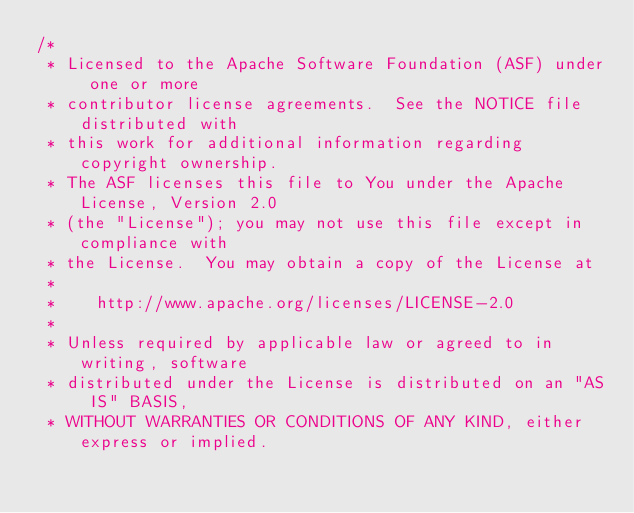Convert code to text. <code><loc_0><loc_0><loc_500><loc_500><_SQL_>/*
 * Licensed to the Apache Software Foundation (ASF) under one or more
 * contributor license agreements.  See the NOTICE file distributed with
 * this work for additional information regarding copyright ownership.
 * The ASF licenses this file to You under the Apache License, Version 2.0
 * (the "License"); you may not use this file except in compliance with
 * the License.  You may obtain a copy of the License at
 *
 *    http://www.apache.org/licenses/LICENSE-2.0
 *
 * Unless required by applicable law or agreed to in writing, software
 * distributed under the License is distributed on an "AS IS" BASIS,
 * WITHOUT WARRANTIES OR CONDITIONS OF ANY KIND, either express or implied.</code> 